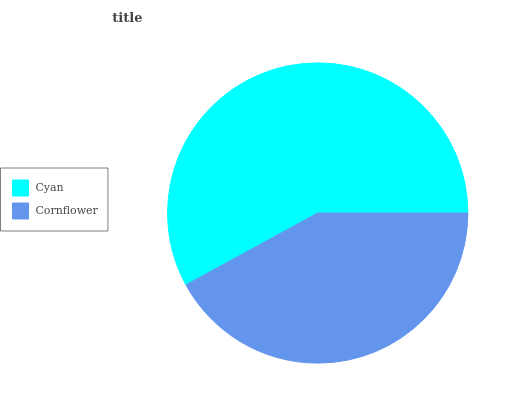Is Cornflower the minimum?
Answer yes or no. Yes. Is Cyan the maximum?
Answer yes or no. Yes. Is Cornflower the maximum?
Answer yes or no. No. Is Cyan greater than Cornflower?
Answer yes or no. Yes. Is Cornflower less than Cyan?
Answer yes or no. Yes. Is Cornflower greater than Cyan?
Answer yes or no. No. Is Cyan less than Cornflower?
Answer yes or no. No. Is Cyan the high median?
Answer yes or no. Yes. Is Cornflower the low median?
Answer yes or no. Yes. Is Cornflower the high median?
Answer yes or no. No. Is Cyan the low median?
Answer yes or no. No. 